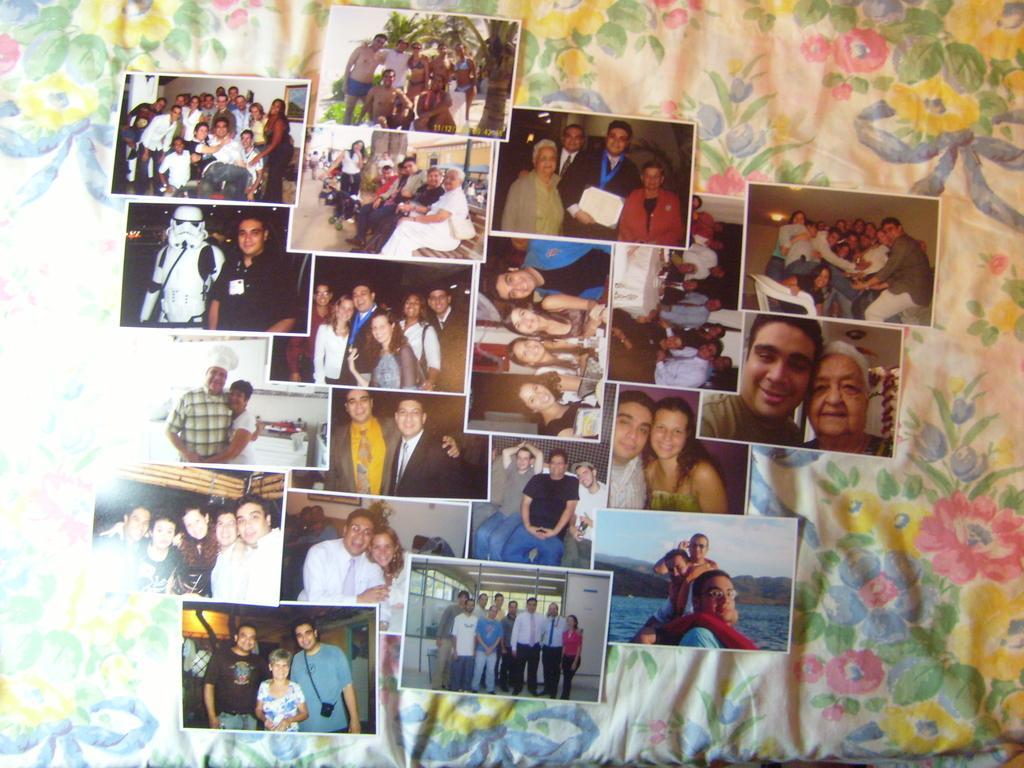How would you summarize this image in a sentence or two? In this image, we can see so many photographs are on the cloth. In these photographs, we can see few people. Few are sitting and standing. Few people are smiling and holding some objects. 